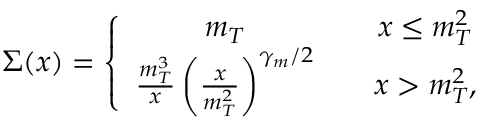<formula> <loc_0><loc_0><loc_500><loc_500>\Sigma ( x ) = \left \{ \begin{array} { c c } { { m _ { T } } } & { { \quad x \leq m _ { T } ^ { 2 } } } \\ { { { \frac { m _ { T } ^ { 3 } } { x } } \left ( { \frac { x } { m _ { T } ^ { 2 } } } \right ) ^ { \gamma _ { m } / 2 } } } & { { \quad x > m _ { T } ^ { 2 } , } } \end{array}</formula> 